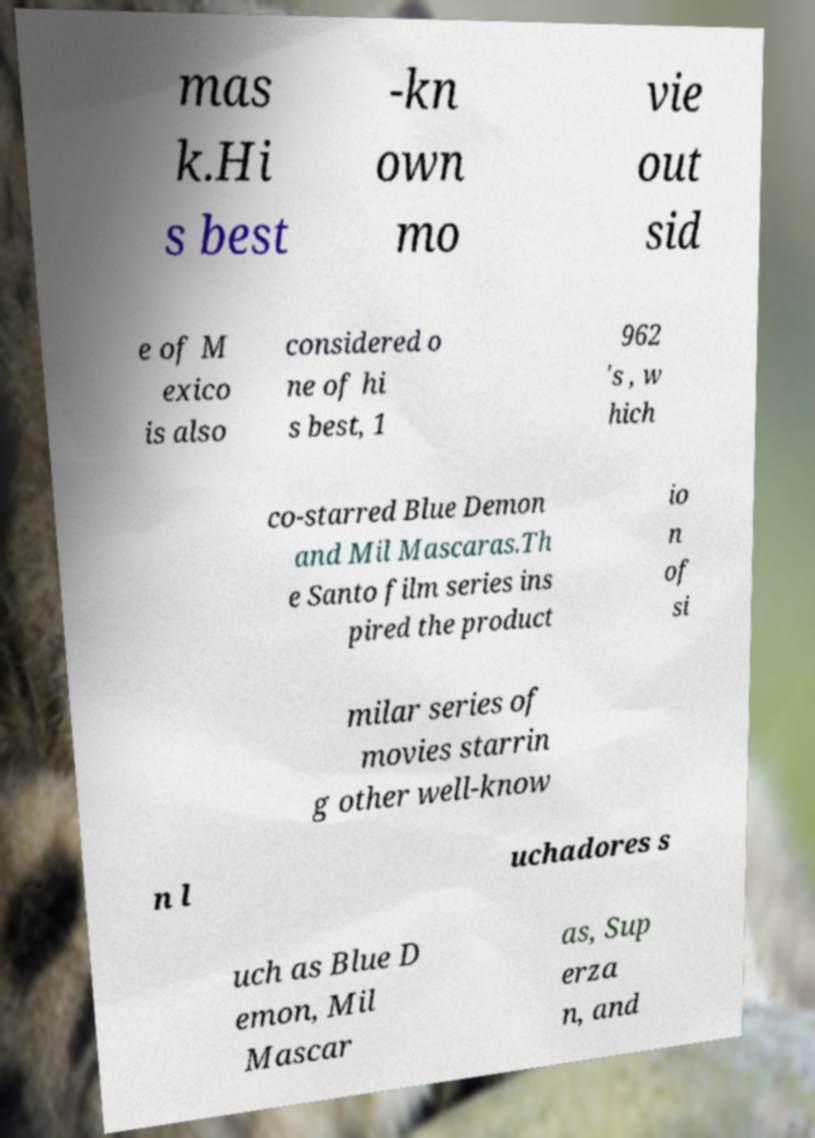What messages or text are displayed in this image? I need them in a readable, typed format. mas k.Hi s best -kn own mo vie out sid e of M exico is also considered o ne of hi s best, 1 962 's , w hich co-starred Blue Demon and Mil Mascaras.Th e Santo film series ins pired the product io n of si milar series of movies starrin g other well-know n l uchadores s uch as Blue D emon, Mil Mascar as, Sup erza n, and 